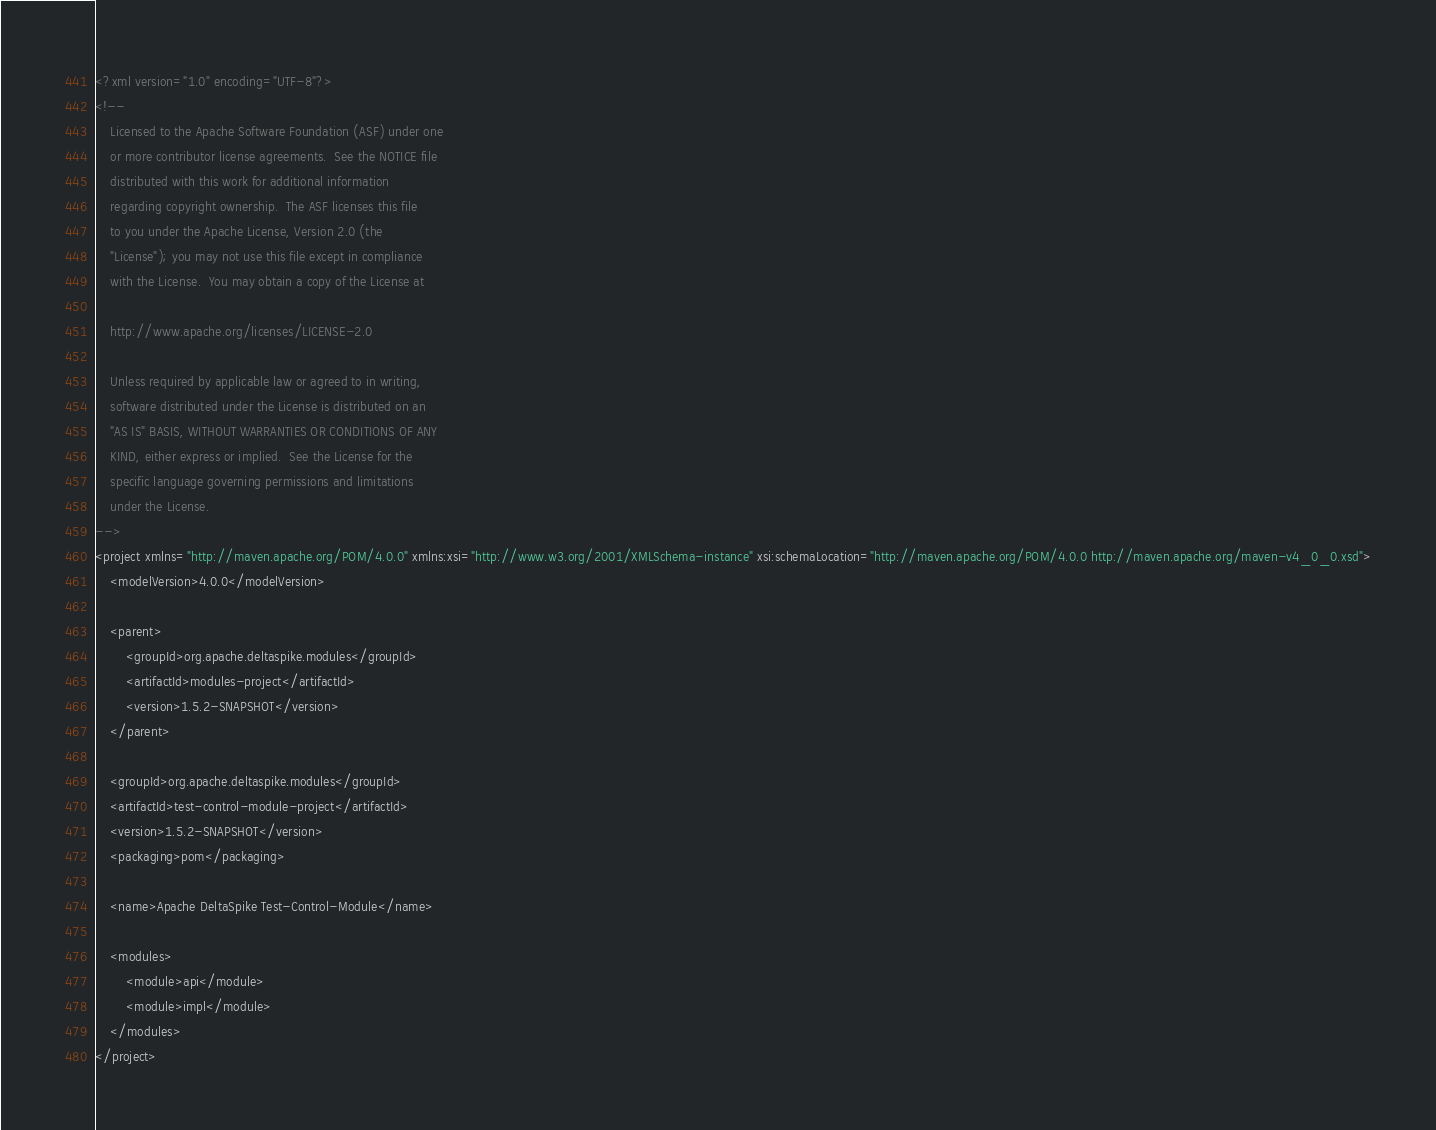Convert code to text. <code><loc_0><loc_0><loc_500><loc_500><_XML_><?xml version="1.0" encoding="UTF-8"?>
<!--
    Licensed to the Apache Software Foundation (ASF) under one
    or more contributor license agreements.  See the NOTICE file
    distributed with this work for additional information
    regarding copyright ownership.  The ASF licenses this file
    to you under the Apache License, Version 2.0 (the
    "License"); you may not use this file except in compliance
    with the License.  You may obtain a copy of the License at

    http://www.apache.org/licenses/LICENSE-2.0

    Unless required by applicable law or agreed to in writing,
    software distributed under the License is distributed on an
    "AS IS" BASIS, WITHOUT WARRANTIES OR CONDITIONS OF ANY
    KIND, either express or implied.  See the License for the
    specific language governing permissions and limitations
    under the License.
-->
<project xmlns="http://maven.apache.org/POM/4.0.0" xmlns:xsi="http://www.w3.org/2001/XMLSchema-instance" xsi:schemaLocation="http://maven.apache.org/POM/4.0.0 http://maven.apache.org/maven-v4_0_0.xsd">
    <modelVersion>4.0.0</modelVersion>

    <parent>
        <groupId>org.apache.deltaspike.modules</groupId>
        <artifactId>modules-project</artifactId>
        <version>1.5.2-SNAPSHOT</version>
    </parent>

    <groupId>org.apache.deltaspike.modules</groupId>
    <artifactId>test-control-module-project</artifactId>
    <version>1.5.2-SNAPSHOT</version>
    <packaging>pom</packaging>

    <name>Apache DeltaSpike Test-Control-Module</name>

    <modules>
        <module>api</module>
        <module>impl</module>
    </modules>
</project>
</code> 